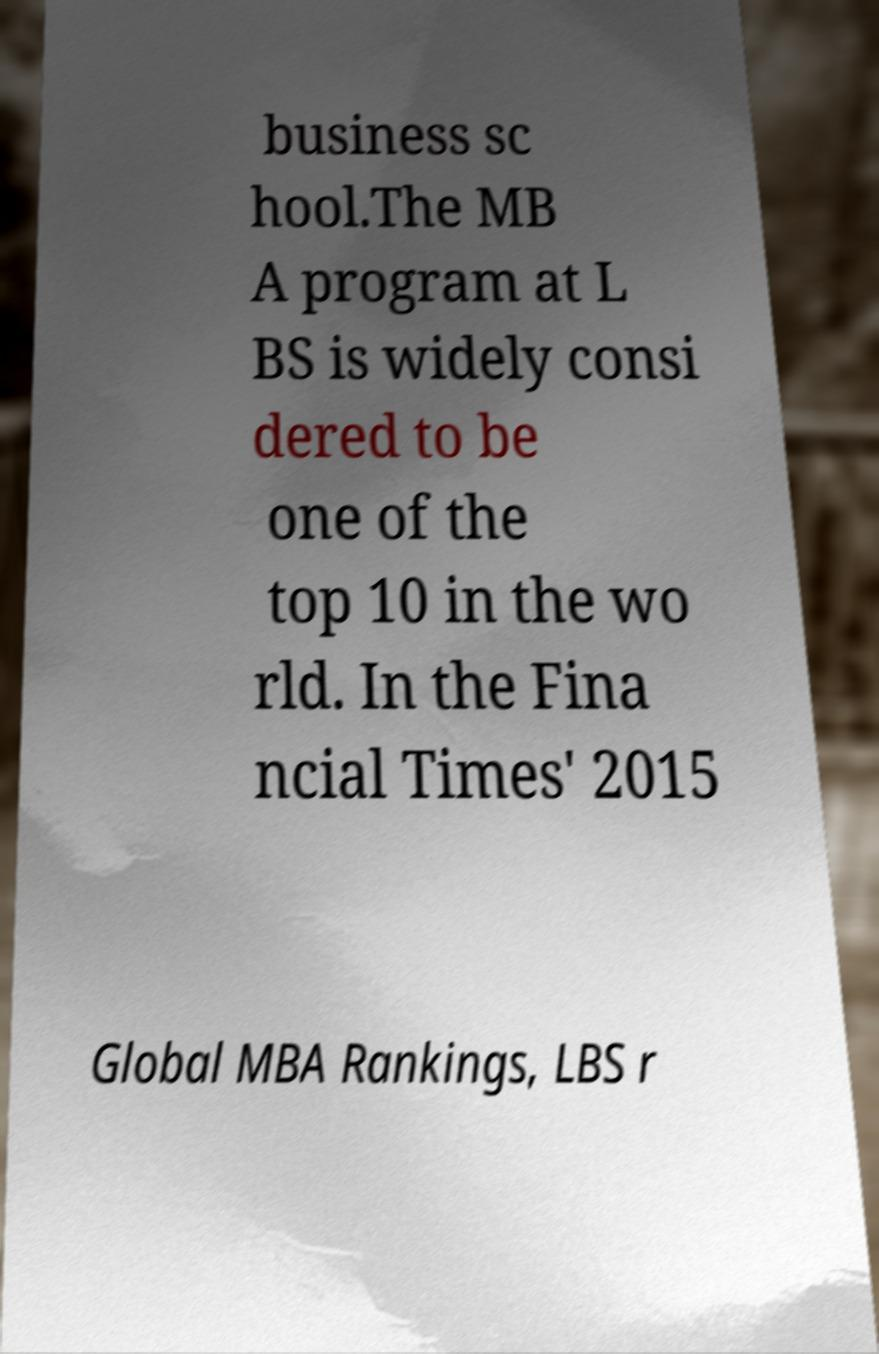What messages or text are displayed in this image? I need them in a readable, typed format. business sc hool.The MB A program at L BS is widely consi dered to be one of the top 10 in the wo rld. In the Fina ncial Times' 2015 Global MBA Rankings, LBS r 